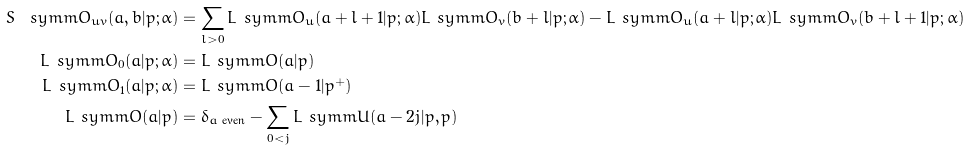<formula> <loc_0><loc_0><loc_500><loc_500>S ^ { \ } s y m m O _ { u v } ( a , b | p ; \alpha ) & = \sum _ { l > 0 } L ^ { \ } s y m m O _ { u } ( a + l + 1 | p ; \alpha ) L ^ { \ } s y m m O _ { v } ( b + l | p ; \alpha ) - L ^ { \ } s y m m O _ { u } ( a + l | p ; \alpha ) L ^ { \ } s y m m O _ { v } ( b + l + 1 | p ; \alpha ) \\ L ^ { \ } s y m m O _ { 0 } ( a | p ; \alpha ) & = L ^ { \ } s y m m O ( a | p ) \\ L ^ { \ } s y m m O _ { 1 } ( a | p ; \alpha ) & = L ^ { \ } s y m m O ( a - 1 | p ^ { + } ) \\ L ^ { \ } s y m m O ( a | p ) & = \delta _ { \text {$a$ even} } - \sum _ { 0 < j } L ^ { \ } s y m m U ( a - 2 j | p , p )</formula> 